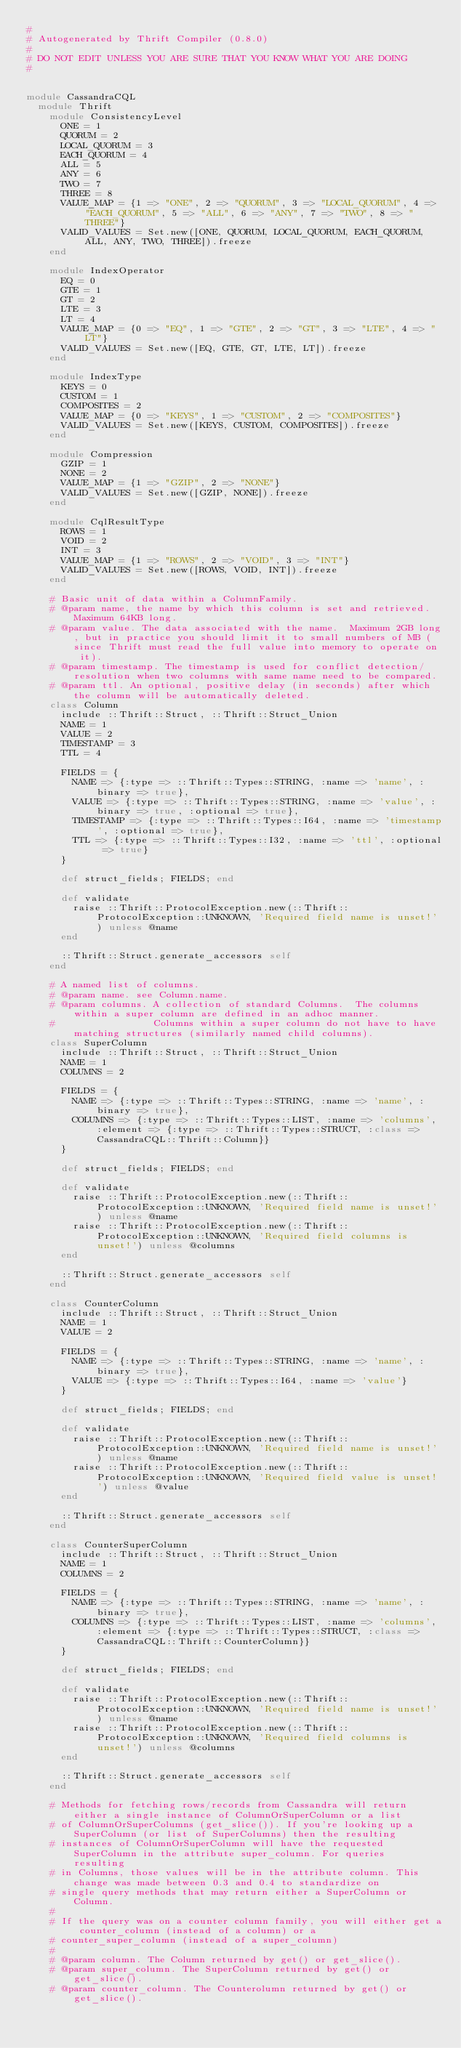Convert code to text. <code><loc_0><loc_0><loc_500><loc_500><_Ruby_>#
# Autogenerated by Thrift Compiler (0.8.0)
#
# DO NOT EDIT UNLESS YOU ARE SURE THAT YOU KNOW WHAT YOU ARE DOING
#


module CassandraCQL
  module Thrift
    module ConsistencyLevel
      ONE = 1
      QUORUM = 2
      LOCAL_QUORUM = 3
      EACH_QUORUM = 4
      ALL = 5
      ANY = 6
      TWO = 7
      THREE = 8
      VALUE_MAP = {1 => "ONE", 2 => "QUORUM", 3 => "LOCAL_QUORUM", 4 => "EACH_QUORUM", 5 => "ALL", 6 => "ANY", 7 => "TWO", 8 => "THREE"}
      VALID_VALUES = Set.new([ONE, QUORUM, LOCAL_QUORUM, EACH_QUORUM, ALL, ANY, TWO, THREE]).freeze
    end

    module IndexOperator
      EQ = 0
      GTE = 1
      GT = 2
      LTE = 3
      LT = 4
      VALUE_MAP = {0 => "EQ", 1 => "GTE", 2 => "GT", 3 => "LTE", 4 => "LT"}
      VALID_VALUES = Set.new([EQ, GTE, GT, LTE, LT]).freeze
    end

    module IndexType
      KEYS = 0
      CUSTOM = 1
      COMPOSITES = 2
      VALUE_MAP = {0 => "KEYS", 1 => "CUSTOM", 2 => "COMPOSITES"}
      VALID_VALUES = Set.new([KEYS, CUSTOM, COMPOSITES]).freeze
    end

    module Compression
      GZIP = 1
      NONE = 2
      VALUE_MAP = {1 => "GZIP", 2 => "NONE"}
      VALID_VALUES = Set.new([GZIP, NONE]).freeze
    end

    module CqlResultType
      ROWS = 1
      VOID = 2
      INT = 3
      VALUE_MAP = {1 => "ROWS", 2 => "VOID", 3 => "INT"}
      VALID_VALUES = Set.new([ROWS, VOID, INT]).freeze
    end

    # Basic unit of data within a ColumnFamily.
    # @param name, the name by which this column is set and retrieved.  Maximum 64KB long.
    # @param value. The data associated with the name.  Maximum 2GB long, but in practice you should limit it to small numbers of MB (since Thrift must read the full value into memory to operate on it).
    # @param timestamp. The timestamp is used for conflict detection/resolution when two columns with same name need to be compared.
    # @param ttl. An optional, positive delay (in seconds) after which the column will be automatically deleted.
    class Column
      include ::Thrift::Struct, ::Thrift::Struct_Union
      NAME = 1
      VALUE = 2
      TIMESTAMP = 3
      TTL = 4

      FIELDS = {
        NAME => {:type => ::Thrift::Types::STRING, :name => 'name', :binary => true},
        VALUE => {:type => ::Thrift::Types::STRING, :name => 'value', :binary => true, :optional => true},
        TIMESTAMP => {:type => ::Thrift::Types::I64, :name => 'timestamp', :optional => true},
        TTL => {:type => ::Thrift::Types::I32, :name => 'ttl', :optional => true}
      }

      def struct_fields; FIELDS; end

      def validate
        raise ::Thrift::ProtocolException.new(::Thrift::ProtocolException::UNKNOWN, 'Required field name is unset!') unless @name
      end

      ::Thrift::Struct.generate_accessors self
    end

    # A named list of columns.
    # @param name. see Column.name.
    # @param columns. A collection of standard Columns.  The columns within a super column are defined in an adhoc manner.
    #                 Columns within a super column do not have to have matching structures (similarly named child columns).
    class SuperColumn
      include ::Thrift::Struct, ::Thrift::Struct_Union
      NAME = 1
      COLUMNS = 2

      FIELDS = {
        NAME => {:type => ::Thrift::Types::STRING, :name => 'name', :binary => true},
        COLUMNS => {:type => ::Thrift::Types::LIST, :name => 'columns', :element => {:type => ::Thrift::Types::STRUCT, :class => CassandraCQL::Thrift::Column}}
      }

      def struct_fields; FIELDS; end

      def validate
        raise ::Thrift::ProtocolException.new(::Thrift::ProtocolException::UNKNOWN, 'Required field name is unset!') unless @name
        raise ::Thrift::ProtocolException.new(::Thrift::ProtocolException::UNKNOWN, 'Required field columns is unset!') unless @columns
      end

      ::Thrift::Struct.generate_accessors self
    end

    class CounterColumn
      include ::Thrift::Struct, ::Thrift::Struct_Union
      NAME = 1
      VALUE = 2

      FIELDS = {
        NAME => {:type => ::Thrift::Types::STRING, :name => 'name', :binary => true},
        VALUE => {:type => ::Thrift::Types::I64, :name => 'value'}
      }

      def struct_fields; FIELDS; end

      def validate
        raise ::Thrift::ProtocolException.new(::Thrift::ProtocolException::UNKNOWN, 'Required field name is unset!') unless @name
        raise ::Thrift::ProtocolException.new(::Thrift::ProtocolException::UNKNOWN, 'Required field value is unset!') unless @value
      end

      ::Thrift::Struct.generate_accessors self
    end

    class CounterSuperColumn
      include ::Thrift::Struct, ::Thrift::Struct_Union
      NAME = 1
      COLUMNS = 2

      FIELDS = {
        NAME => {:type => ::Thrift::Types::STRING, :name => 'name', :binary => true},
        COLUMNS => {:type => ::Thrift::Types::LIST, :name => 'columns', :element => {:type => ::Thrift::Types::STRUCT, :class => CassandraCQL::Thrift::CounterColumn}}
      }

      def struct_fields; FIELDS; end

      def validate
        raise ::Thrift::ProtocolException.new(::Thrift::ProtocolException::UNKNOWN, 'Required field name is unset!') unless @name
        raise ::Thrift::ProtocolException.new(::Thrift::ProtocolException::UNKNOWN, 'Required field columns is unset!') unless @columns
      end

      ::Thrift::Struct.generate_accessors self
    end

    # Methods for fetching rows/records from Cassandra will return either a single instance of ColumnOrSuperColumn or a list
    # of ColumnOrSuperColumns (get_slice()). If you're looking up a SuperColumn (or list of SuperColumns) then the resulting
    # instances of ColumnOrSuperColumn will have the requested SuperColumn in the attribute super_column. For queries resulting
    # in Columns, those values will be in the attribute column. This change was made between 0.3 and 0.4 to standardize on
    # single query methods that may return either a SuperColumn or Column.
    # 
    # If the query was on a counter column family, you will either get a counter_column (instead of a column) or a
    # counter_super_column (instead of a super_column)
    # 
    # @param column. The Column returned by get() or get_slice().
    # @param super_column. The SuperColumn returned by get() or get_slice().
    # @param counter_column. The Counterolumn returned by get() or get_slice().</code> 